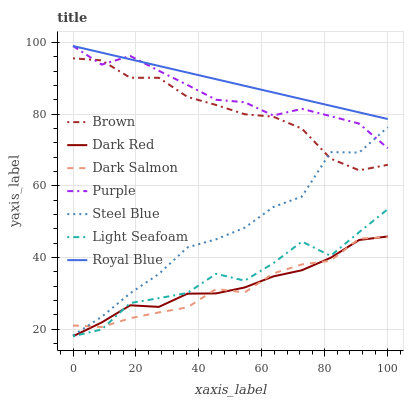Does Dark Salmon have the minimum area under the curve?
Answer yes or no. Yes. Does Royal Blue have the maximum area under the curve?
Answer yes or no. Yes. Does Purple have the minimum area under the curve?
Answer yes or no. No. Does Purple have the maximum area under the curve?
Answer yes or no. No. Is Royal Blue the smoothest?
Answer yes or no. Yes. Is Light Seafoam the roughest?
Answer yes or no. Yes. Is Purple the smoothest?
Answer yes or no. No. Is Purple the roughest?
Answer yes or no. No. Does Dark Red have the lowest value?
Answer yes or no. Yes. Does Purple have the lowest value?
Answer yes or no. No. Does Royal Blue have the highest value?
Answer yes or no. Yes. Does Dark Red have the highest value?
Answer yes or no. No. Is Dark Red less than Brown?
Answer yes or no. Yes. Is Royal Blue greater than Dark Red?
Answer yes or no. Yes. Does Royal Blue intersect Purple?
Answer yes or no. Yes. Is Royal Blue less than Purple?
Answer yes or no. No. Is Royal Blue greater than Purple?
Answer yes or no. No. Does Dark Red intersect Brown?
Answer yes or no. No. 